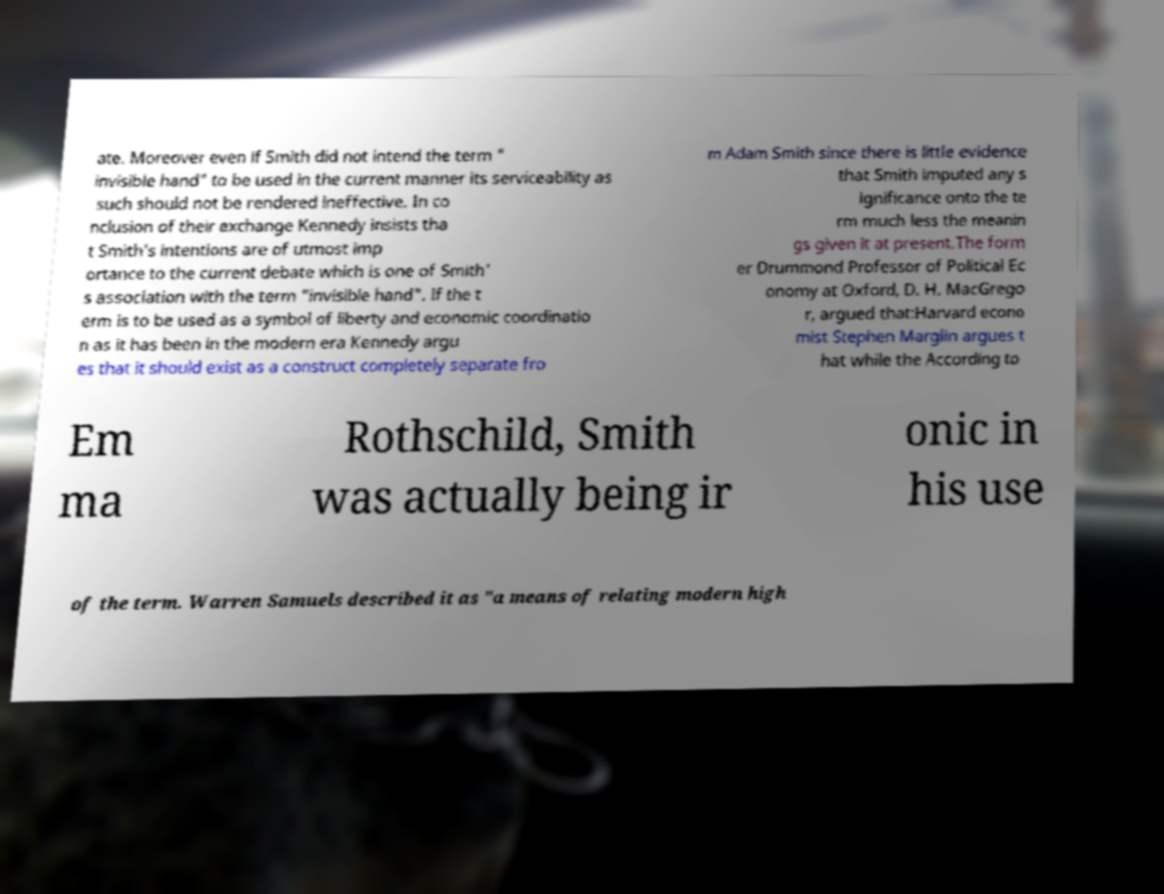Could you assist in decoding the text presented in this image and type it out clearly? ate. Moreover even if Smith did not intend the term " invisible hand" to be used in the current manner its serviceability as such should not be rendered ineffective. In co nclusion of their exchange Kennedy insists tha t Smith's intentions are of utmost imp ortance to the current debate which is one of Smith' s association with the term "invisible hand". If the t erm is to be used as a symbol of liberty and economic coordinatio n as it has been in the modern era Kennedy argu es that it should exist as a construct completely separate fro m Adam Smith since there is little evidence that Smith imputed any s ignificance onto the te rm much less the meanin gs given it at present.The form er Drummond Professor of Political Ec onomy at Oxford, D. H. MacGrego r, argued that:Harvard econo mist Stephen Marglin argues t hat while the According to Em ma Rothschild, Smith was actually being ir onic in his use of the term. Warren Samuels described it as "a means of relating modern high 